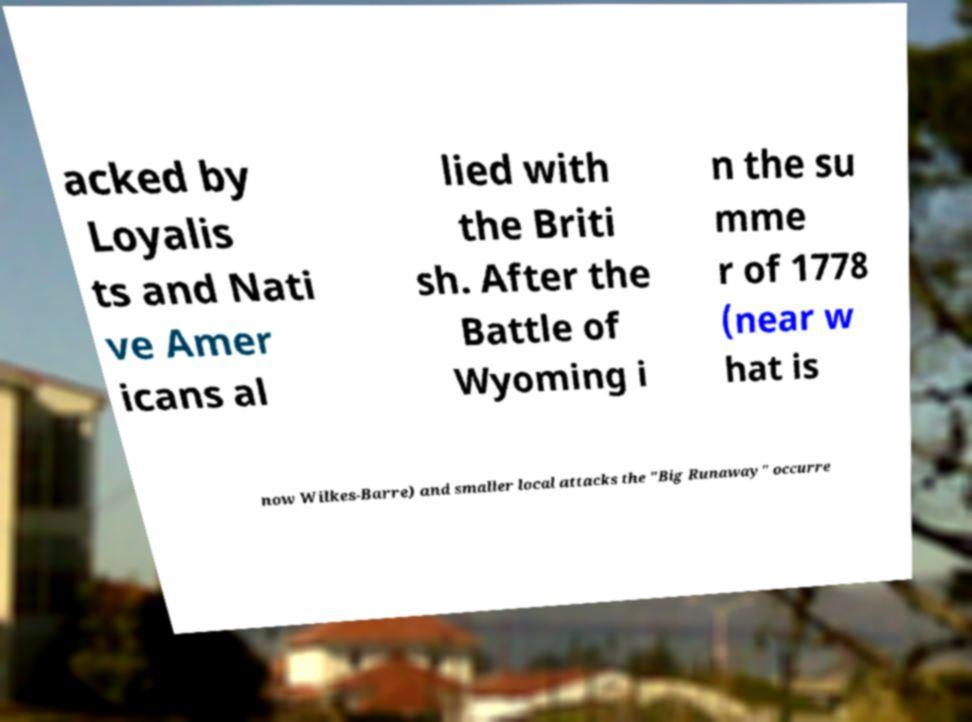For documentation purposes, I need the text within this image transcribed. Could you provide that? acked by Loyalis ts and Nati ve Amer icans al lied with the Briti sh. After the Battle of Wyoming i n the su mme r of 1778 (near w hat is now Wilkes-Barre) and smaller local attacks the "Big Runaway" occurre 